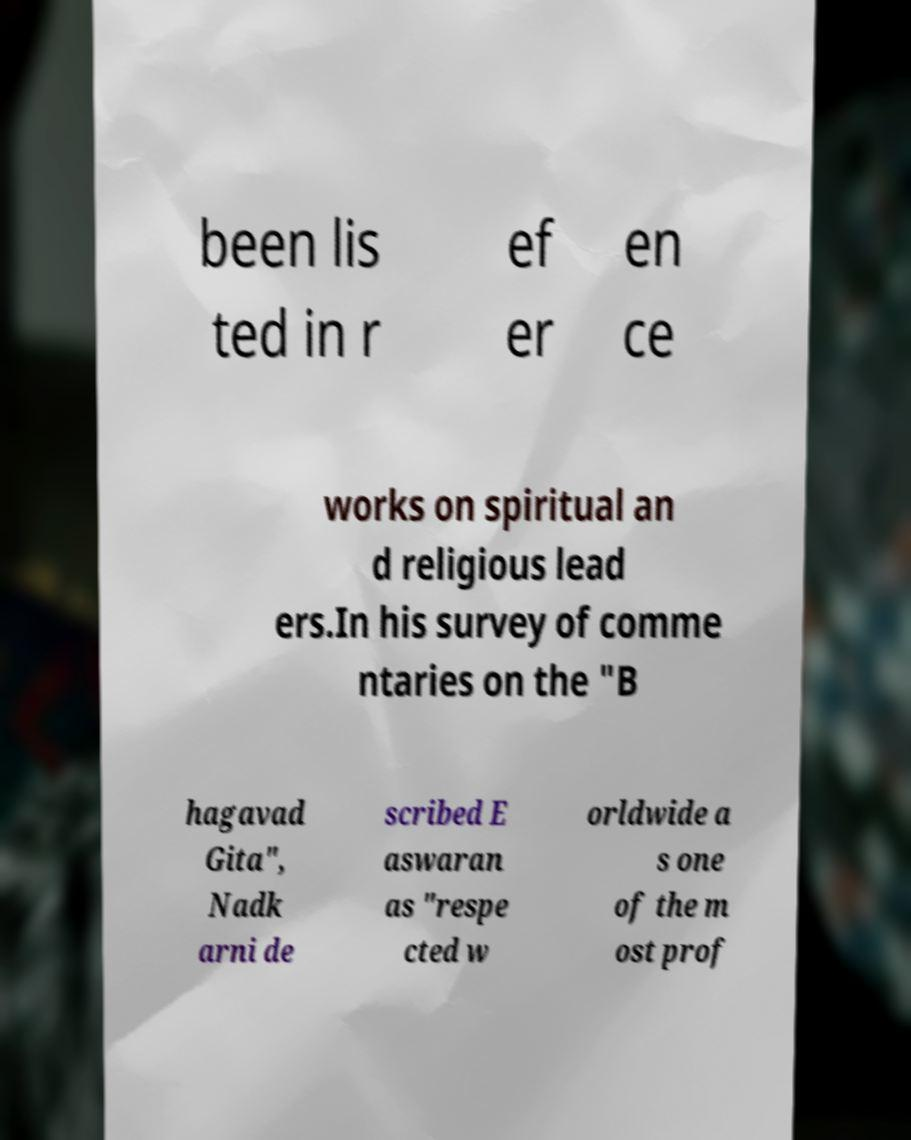Can you read and provide the text displayed in the image?This photo seems to have some interesting text. Can you extract and type it out for me? been lis ted in r ef er en ce works on spiritual an d religious lead ers.In his survey of comme ntaries on the "B hagavad Gita", Nadk arni de scribed E aswaran as "respe cted w orldwide a s one of the m ost prof 